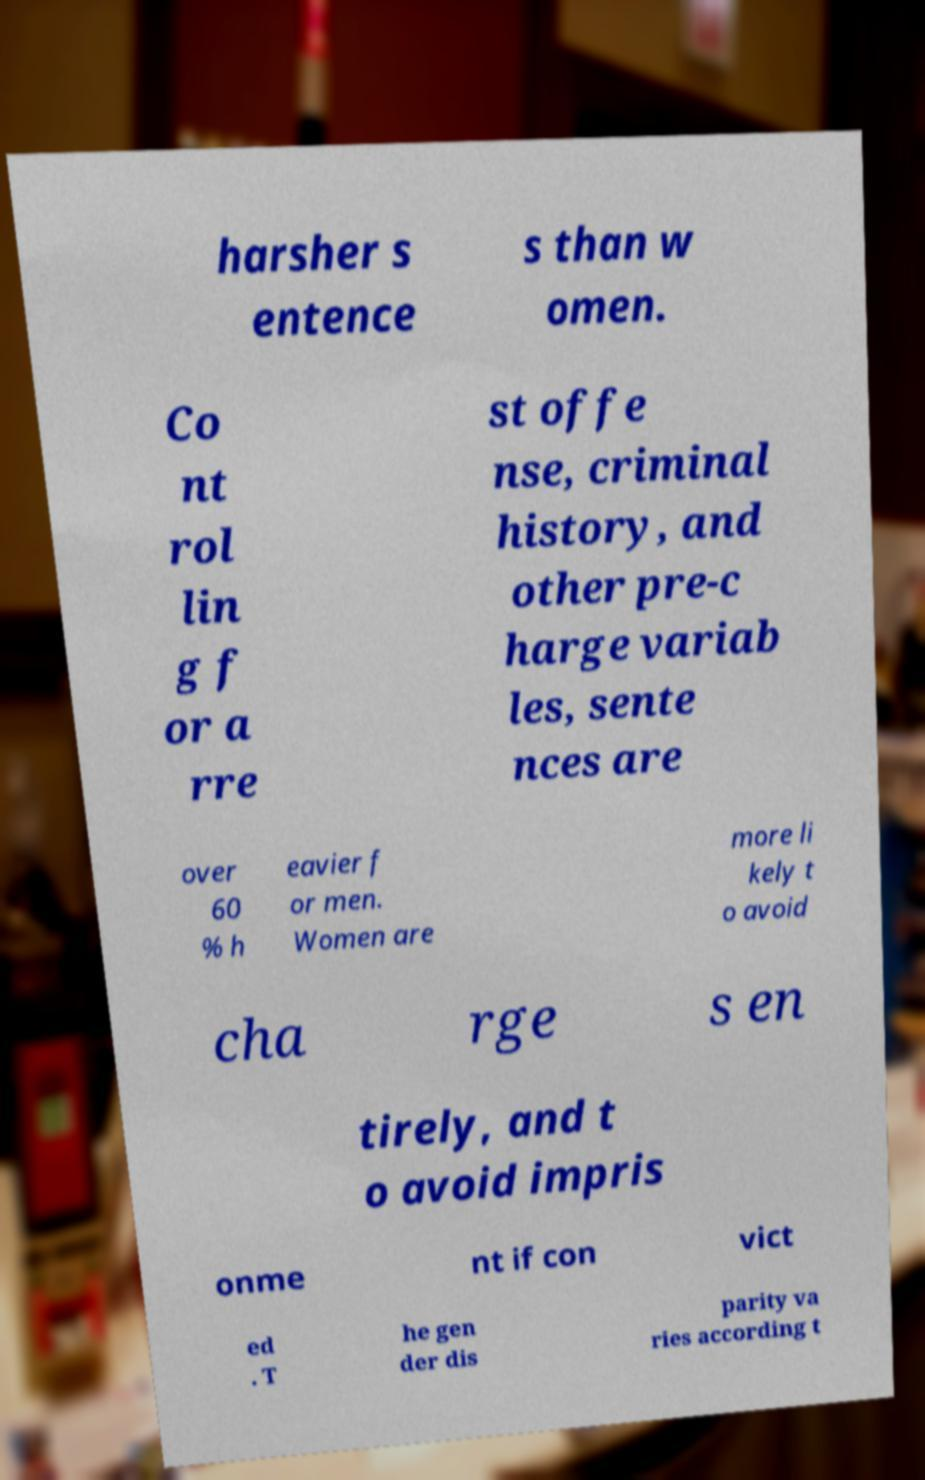Please read and relay the text visible in this image. What does it say? harsher s entence s than w omen. Co nt rol lin g f or a rre st offe nse, criminal history, and other pre-c harge variab les, sente nces are over 60 % h eavier f or men. Women are more li kely t o avoid cha rge s en tirely, and t o avoid impris onme nt if con vict ed . T he gen der dis parity va ries according t 